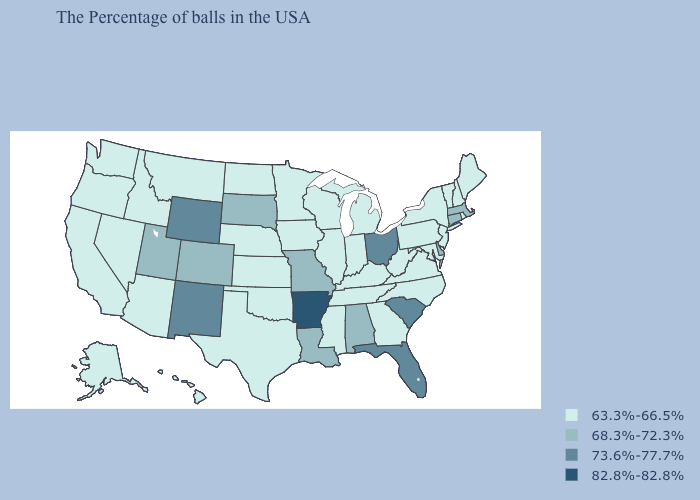Does Virginia have the highest value in the South?
Concise answer only. No. What is the highest value in the USA?
Keep it brief. 82.8%-82.8%. Which states have the lowest value in the West?
Be succinct. Montana, Arizona, Idaho, Nevada, California, Washington, Oregon, Alaska, Hawaii. What is the highest value in the Northeast ?
Quick response, please. 68.3%-72.3%. What is the value of Connecticut?
Answer briefly. 68.3%-72.3%. What is the value of Connecticut?
Short answer required. 68.3%-72.3%. Does Utah have the highest value in the USA?
Concise answer only. No. Name the states that have a value in the range 82.8%-82.8%?
Give a very brief answer. Arkansas. Does Arkansas have the highest value in the USA?
Answer briefly. Yes. Name the states that have a value in the range 73.6%-77.7%?
Answer briefly. South Carolina, Ohio, Florida, Wyoming, New Mexico. Which states hav the highest value in the West?
Keep it brief. Wyoming, New Mexico. How many symbols are there in the legend?
Keep it brief. 4. Which states have the lowest value in the South?
Give a very brief answer. Maryland, Virginia, North Carolina, West Virginia, Georgia, Kentucky, Tennessee, Mississippi, Oklahoma, Texas. What is the value of New Jersey?
Concise answer only. 63.3%-66.5%. Which states have the lowest value in the USA?
Answer briefly. Maine, Rhode Island, New Hampshire, Vermont, New York, New Jersey, Maryland, Pennsylvania, Virginia, North Carolina, West Virginia, Georgia, Michigan, Kentucky, Indiana, Tennessee, Wisconsin, Illinois, Mississippi, Minnesota, Iowa, Kansas, Nebraska, Oklahoma, Texas, North Dakota, Montana, Arizona, Idaho, Nevada, California, Washington, Oregon, Alaska, Hawaii. 